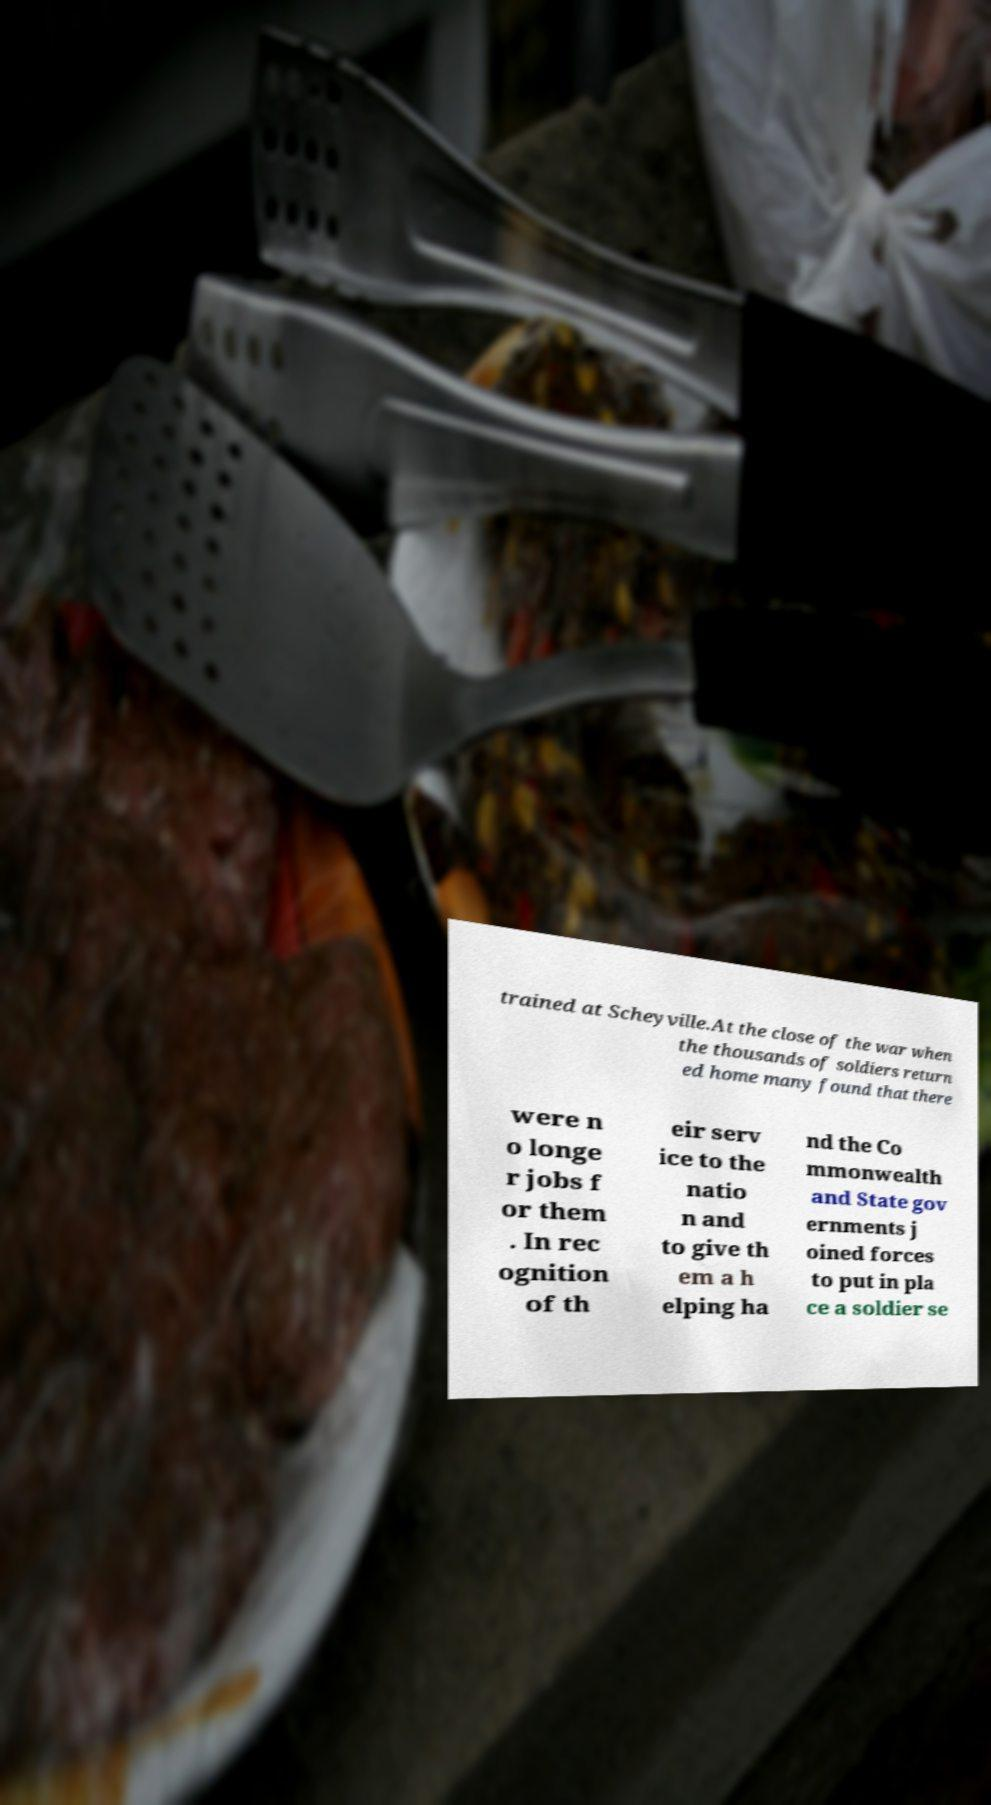I need the written content from this picture converted into text. Can you do that? trained at Scheyville.At the close of the war when the thousands of soldiers return ed home many found that there were n o longe r jobs f or them . In rec ognition of th eir serv ice to the natio n and to give th em a h elping ha nd the Co mmonwealth and State gov ernments j oined forces to put in pla ce a soldier se 